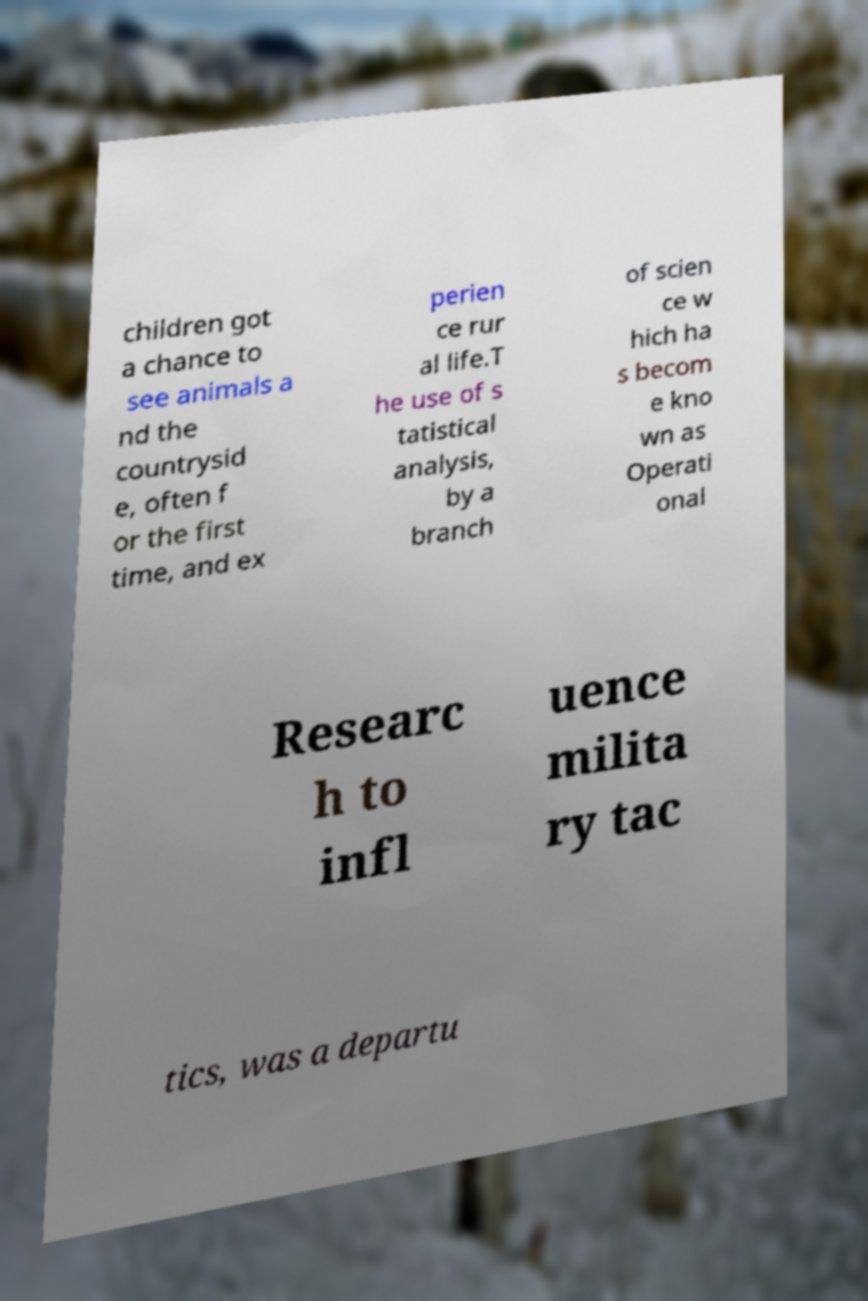Please read and relay the text visible in this image. What does it say? children got a chance to see animals a nd the countrysid e, often f or the first time, and ex perien ce rur al life.T he use of s tatistical analysis, by a branch of scien ce w hich ha s becom e kno wn as Operati onal Researc h to infl uence milita ry tac tics, was a departu 